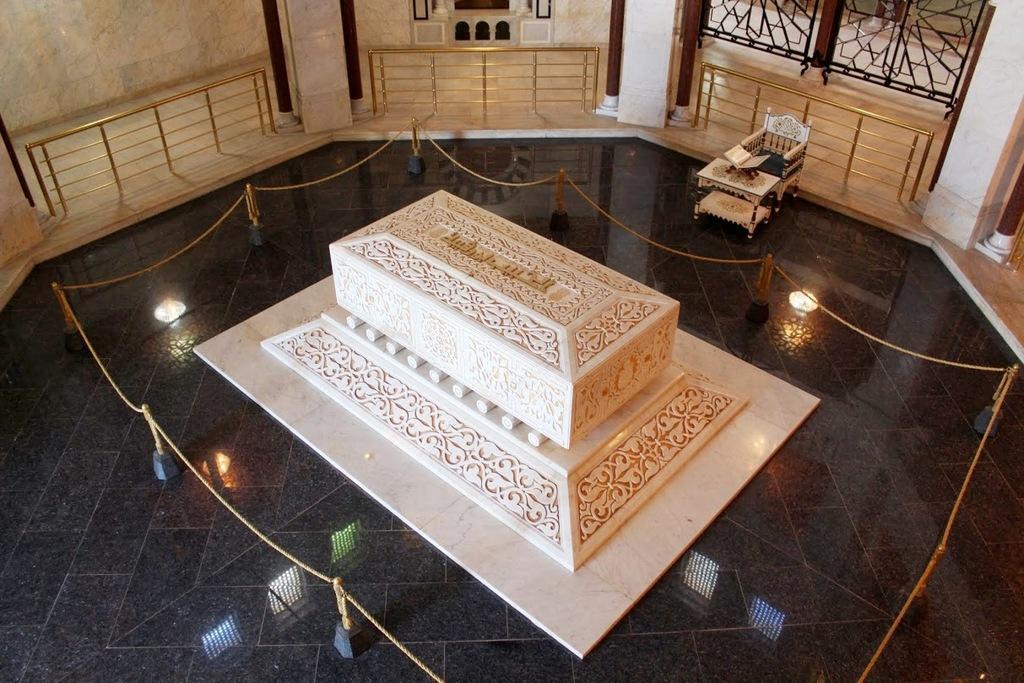Could you give a brief overview of what you see in this image? In the image we can see there is a grave on the ground and there is a book kept on the table and there is a chair. There is a chain fencing around the grave, there are iron railings and iron poles. 